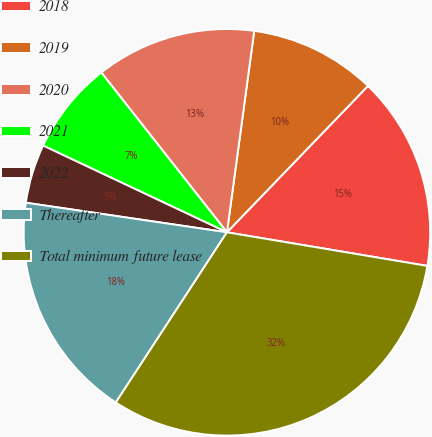Convert chart. <chart><loc_0><loc_0><loc_500><loc_500><pie_chart><fcel>2018<fcel>2019<fcel>2020<fcel>2021<fcel>2022<fcel>Thereafter<fcel>Total minimum future lease<nl><fcel>15.44%<fcel>10.06%<fcel>12.75%<fcel>7.38%<fcel>4.69%<fcel>18.12%<fcel>31.56%<nl></chart> 